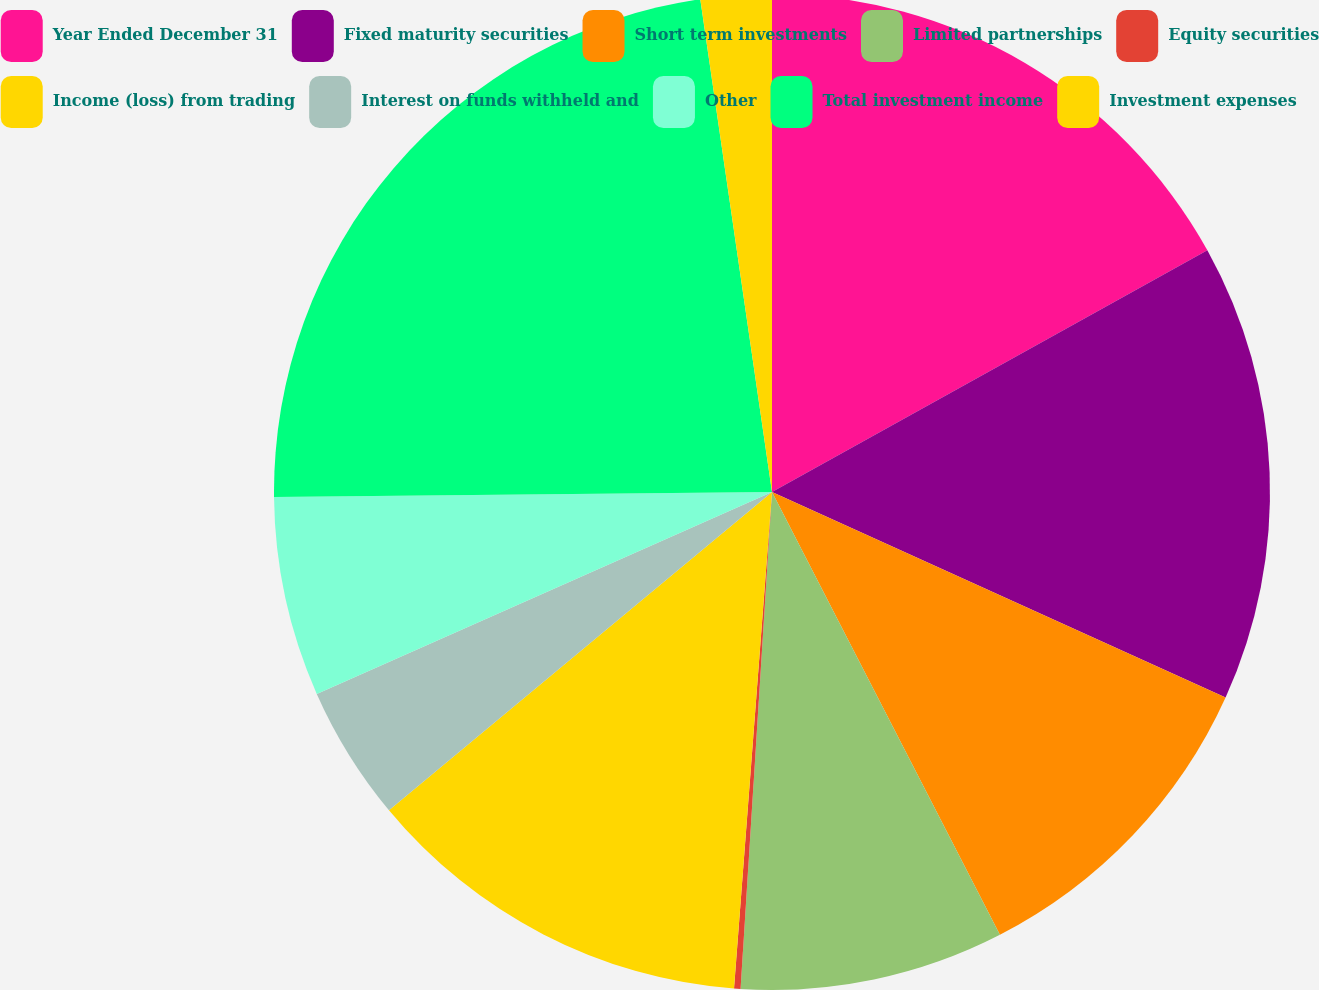Convert chart. <chart><loc_0><loc_0><loc_500><loc_500><pie_chart><fcel>Year Ended December 31<fcel>Fixed maturity securities<fcel>Short term investments<fcel>Limited partnerships<fcel>Equity securities<fcel>Income (loss) from trading<fcel>Interest on funds withheld and<fcel>Other<fcel>Total investment income<fcel>Investment expenses<nl><fcel>16.93%<fcel>14.84%<fcel>10.66%<fcel>8.57%<fcel>0.21%<fcel>12.75%<fcel>4.39%<fcel>6.48%<fcel>22.86%<fcel>2.3%<nl></chart> 